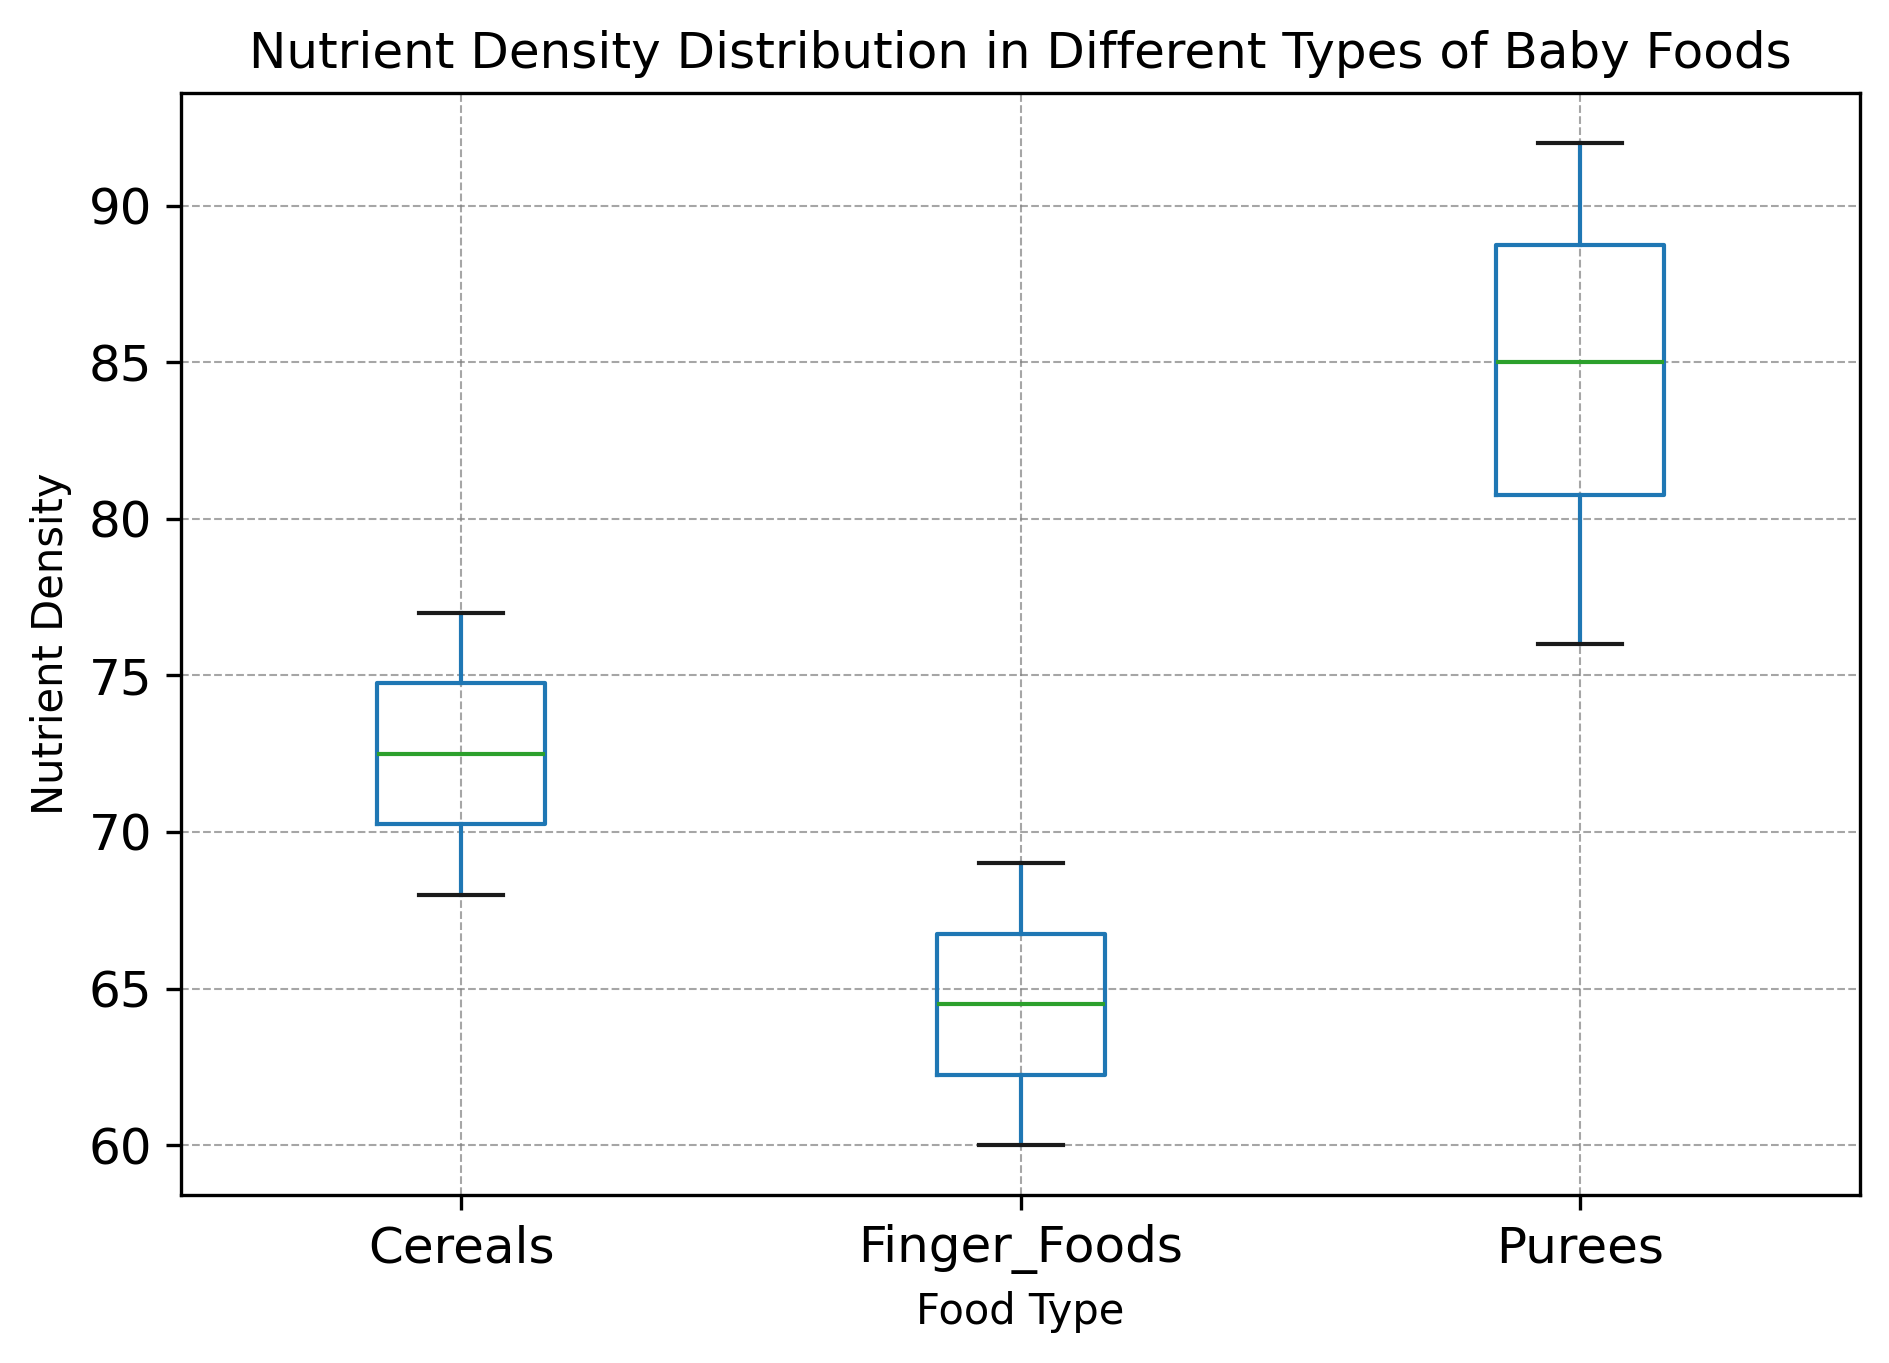what type of baby food has the highest median nutrient density? To determine this, look at where the median line is within each boxplot. The median is represented by the line inside the box. The highest median line appears in the "Purees" category.
Answer: Purees which category shows the greatest variability in nutrient density? Variability in a boxplot can be assessed by looking at the length of the box and the range of the whiskers. Here, "Purees" has the longest whiskers and box, indicating the highest variability in nutrient density.
Answer: Purees what's the interquartile range (IQR) for cereals? To find the IQR, subtract the first quartile (bottom of the box) from the third quartile (top of the box) for the "Cereals" category. The bottom of the box appears around 69 and the top around 75, so the IQR is 75 - 69 = 6.
Answer: 6 which type of baby food has the lowest maximum nutrient density? The maximum nutrient density is represented by the top whisker of each boxplot. The "Finger Foods" category has the lowest maximum, reaching only up to about 69.
Answer: Finger Foods compare the range of nutrient densities between purees and finger foods To compare the ranges, look at the distance between the top and bottom whiskers for "Purees" and "Finger Foods". "Purees" ranges from about 76 to 92, and "Finger Foods" ranges from 60 to 69. The range for "Purees" is 92 - 76 = 16, while for "Finger Foods" it's 69 - 60 = 9.
Answer: Purees have a larger range what's the midpoint of the range of nutrient density for finger foods? The midpoint is the average of the minimum and maximum values of the range. For "Finger Foods", the range is 60 to 69. The midpoint is (60 + 69) / 2 = 64.5.
Answer: 64.5 which type of baby food has the smallest lower whisker value? The lower whisker represents the minimum value of the data distribution. "Finger Foods" have the smallest lower whisker value, which is around 60.
Answer: Finger Foods do any categories have potential outliers and if so, which? Outliers are often represented by individual dots outside the whiskers. In this plot, "Purees" and "Cereals" have no dots indicating there are no outliers.
Answer: No categories have outliers compare the median nutrient density of purees and cereals The median is the line inside the box. For "Purees" the median is around 85, and for "Cereals" it is around 73. The median for "Purees" is higher than for "Cereals".
Answer: Purees have a higher median 